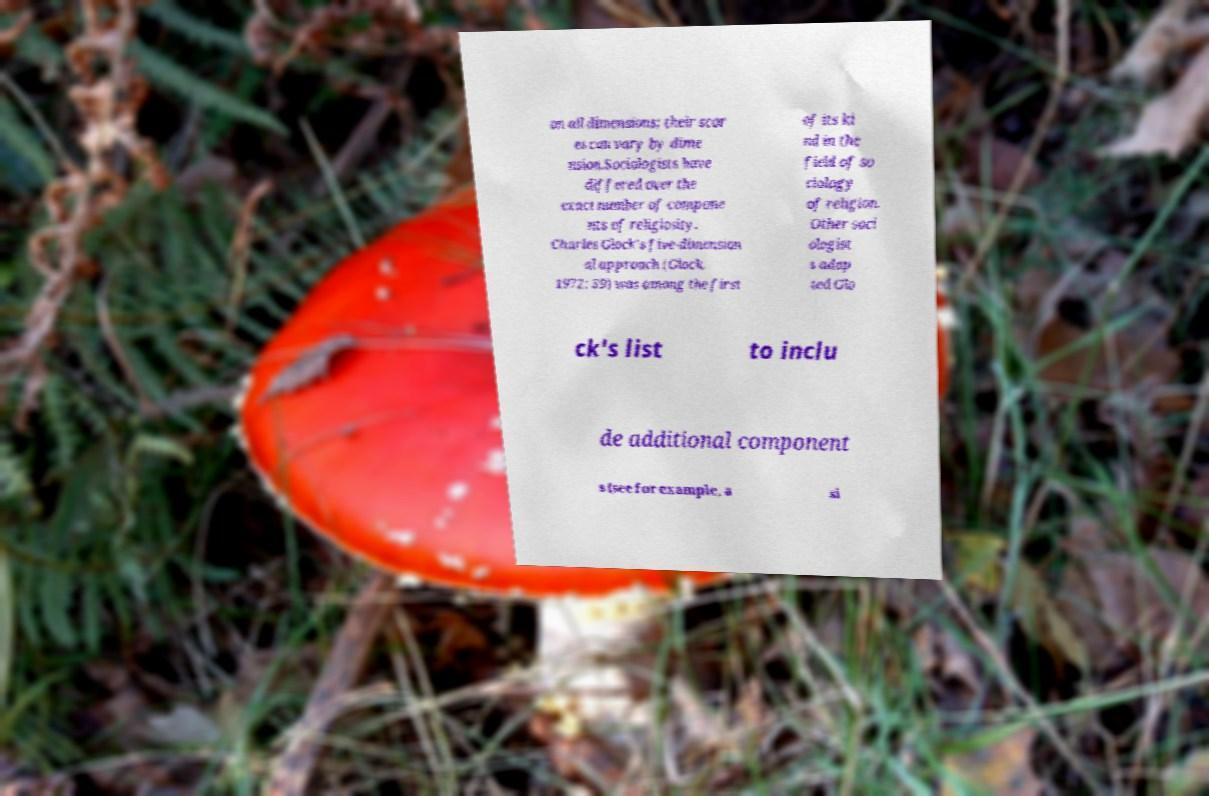Can you read and provide the text displayed in the image?This photo seems to have some interesting text. Can you extract and type it out for me? on all dimensions; their scor es can vary by dime nsion.Sociologists have differed over the exact number of compone nts of religiosity. Charles Glock's five-dimension al approach (Glock, 1972: 39) was among the first of its ki nd in the field of so ciology of religion. Other soci ologist s adap ted Glo ck's list to inclu de additional component s (see for example, a si 